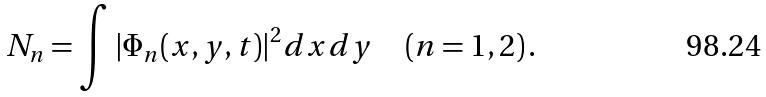Convert formula to latex. <formula><loc_0><loc_0><loc_500><loc_500>N _ { n } = \int | \Phi _ { n } ( x , y , t ) | ^ { 2 } d x d y \quad ( n = 1 , 2 ) \, .</formula> 